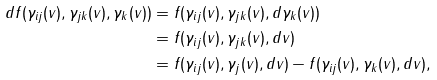<formula> <loc_0><loc_0><loc_500><loc_500>d f ( \gamma _ { i j } ( v ) , \gamma _ { j k } ( v ) , \gamma _ { k } ( v ) ) & = f ( \gamma _ { i j } ( v ) , \gamma _ { j k } ( v ) , d \gamma _ { k } ( v ) ) \\ & = f ( \gamma _ { i j } ( v ) , \gamma _ { j k } ( v ) , d v ) \\ & = f ( \gamma _ { i j } ( v ) , \gamma _ { j } ( v ) , d v ) - f ( \gamma _ { i j } ( v ) , \gamma _ { k } ( v ) , d v ) ,</formula> 